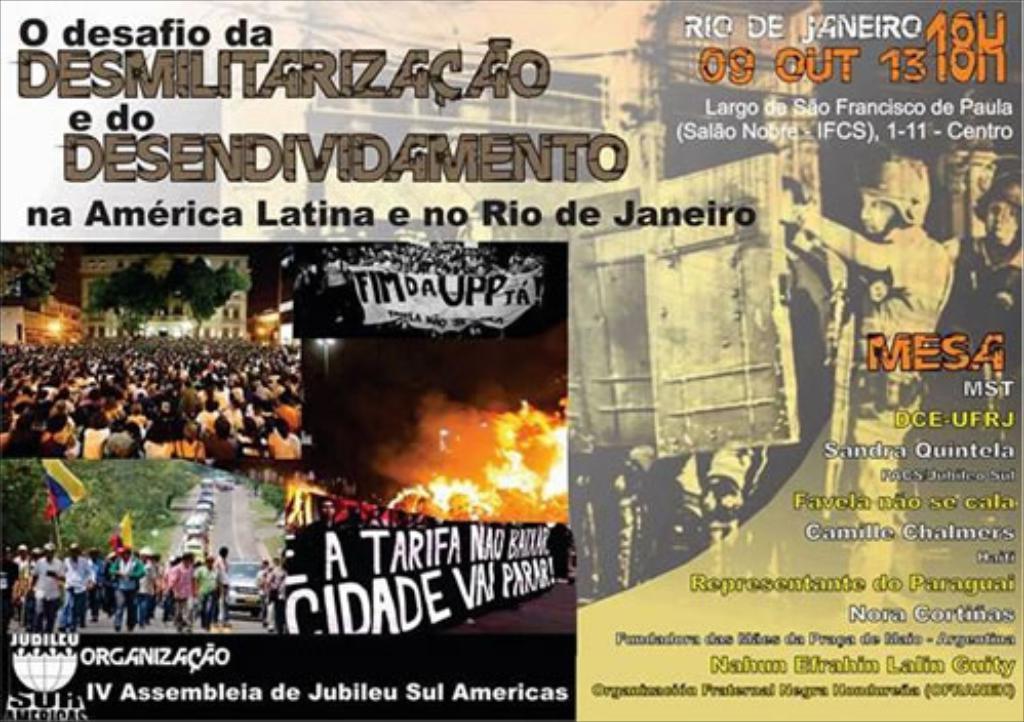What country is printed in black?
Give a very brief answer. Brazil. Some rockets image?
Your answer should be compact. No. 